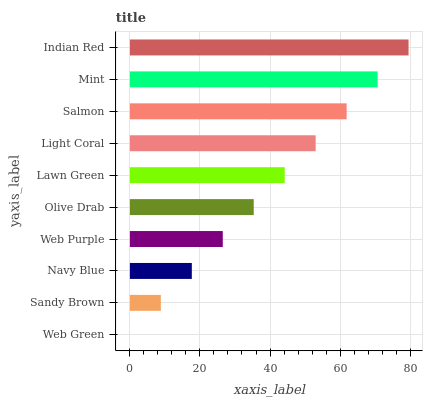Is Web Green the minimum?
Answer yes or no. Yes. Is Indian Red the maximum?
Answer yes or no. Yes. Is Sandy Brown the minimum?
Answer yes or no. No. Is Sandy Brown the maximum?
Answer yes or no. No. Is Sandy Brown greater than Web Green?
Answer yes or no. Yes. Is Web Green less than Sandy Brown?
Answer yes or no. Yes. Is Web Green greater than Sandy Brown?
Answer yes or no. No. Is Sandy Brown less than Web Green?
Answer yes or no. No. Is Lawn Green the high median?
Answer yes or no. Yes. Is Olive Drab the low median?
Answer yes or no. Yes. Is Navy Blue the high median?
Answer yes or no. No. Is Navy Blue the low median?
Answer yes or no. No. 